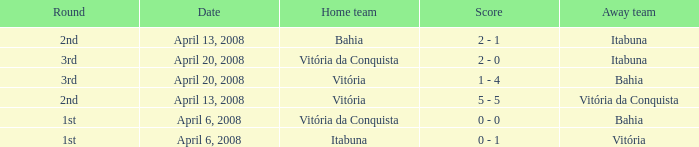Who played as the home team when Vitória was the away team? Itabuna. 